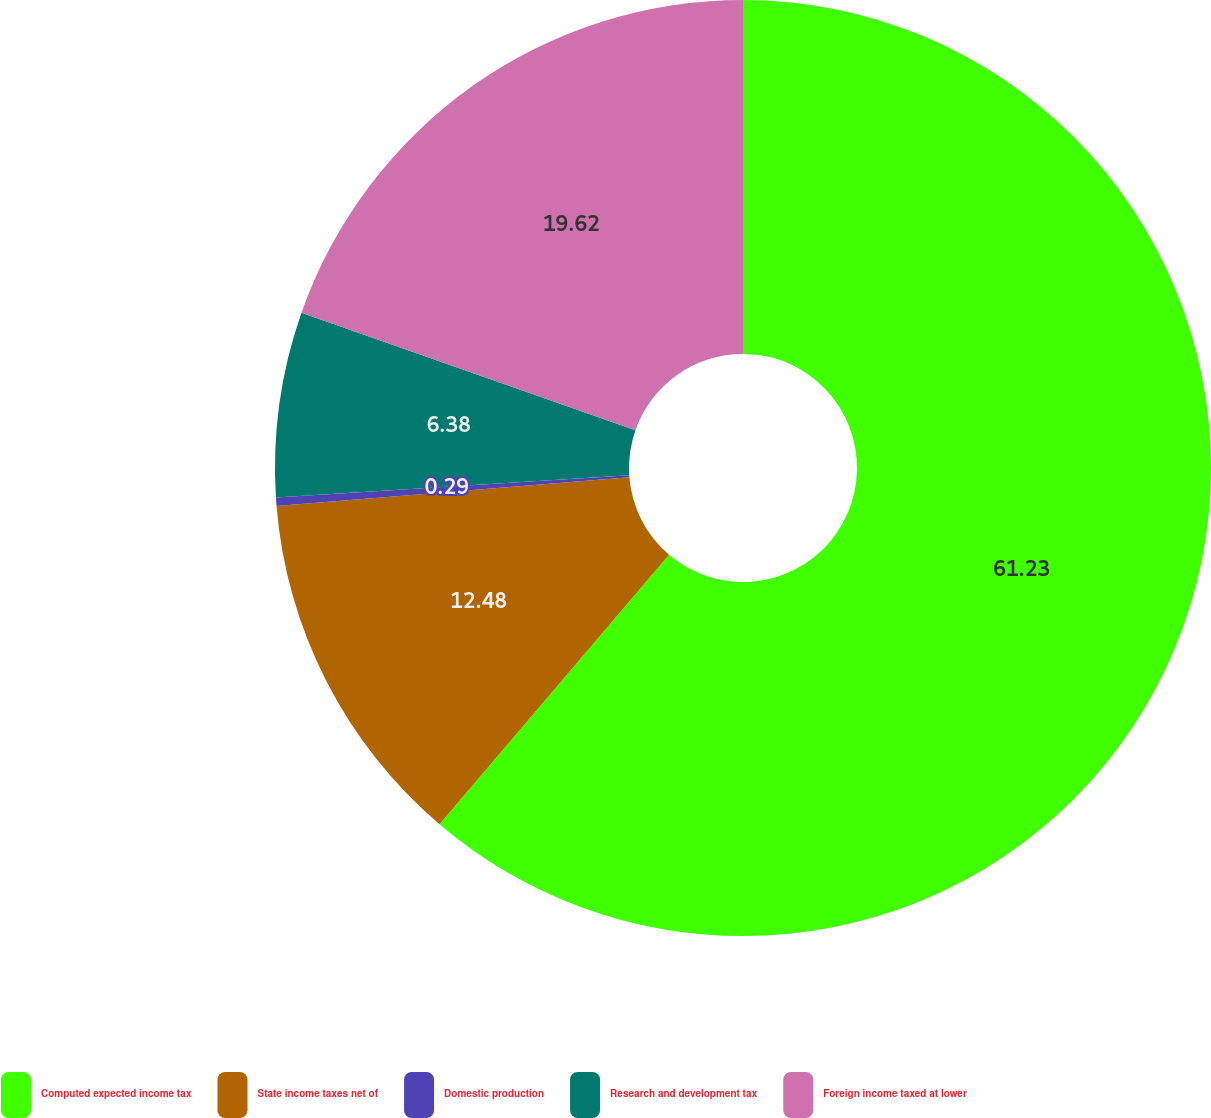Convert chart to OTSL. <chart><loc_0><loc_0><loc_500><loc_500><pie_chart><fcel>Computed expected income tax<fcel>State income taxes net of<fcel>Domestic production<fcel>Research and development tax<fcel>Foreign income taxed at lower<nl><fcel>61.23%<fcel>12.48%<fcel>0.29%<fcel>6.38%<fcel>19.62%<nl></chart> 